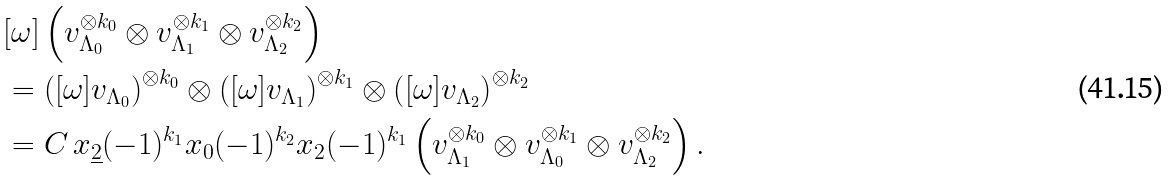<formula> <loc_0><loc_0><loc_500><loc_500>& [ \omega ] \left ( v _ { \Lambda _ { 0 } } ^ { \otimes k _ { 0 } } \otimes v _ { \Lambda _ { 1 } } ^ { \otimes k _ { 1 } } \otimes v _ { \Lambda _ { 2 } } ^ { \otimes k _ { 2 } } \right ) \\ & = \left ( [ \omega ] v _ { \Lambda _ { 0 } } \right ) ^ { \otimes k _ { 0 } } \otimes \left ( [ \omega ] v _ { \Lambda _ { 1 } } \right ) ^ { \otimes k _ { 1 } } \otimes \left ( [ \omega ] v _ { \Lambda _ { 2 } } \right ) ^ { \otimes k _ { 2 } } \\ & = C \, x _ { \underline { 2 } } ( - 1 ) ^ { k _ { 1 } } x _ { 0 } ( - 1 ) ^ { k _ { 2 } } x _ { 2 } ( - 1 ) ^ { k _ { 1 } } \left ( v _ { \Lambda _ { 1 } } ^ { \otimes k _ { 0 } } \otimes v _ { \Lambda _ { 0 } } ^ { \otimes k _ { 1 } } \otimes v _ { \Lambda _ { 2 } } ^ { \otimes k _ { 2 } } \right ) .</formula> 